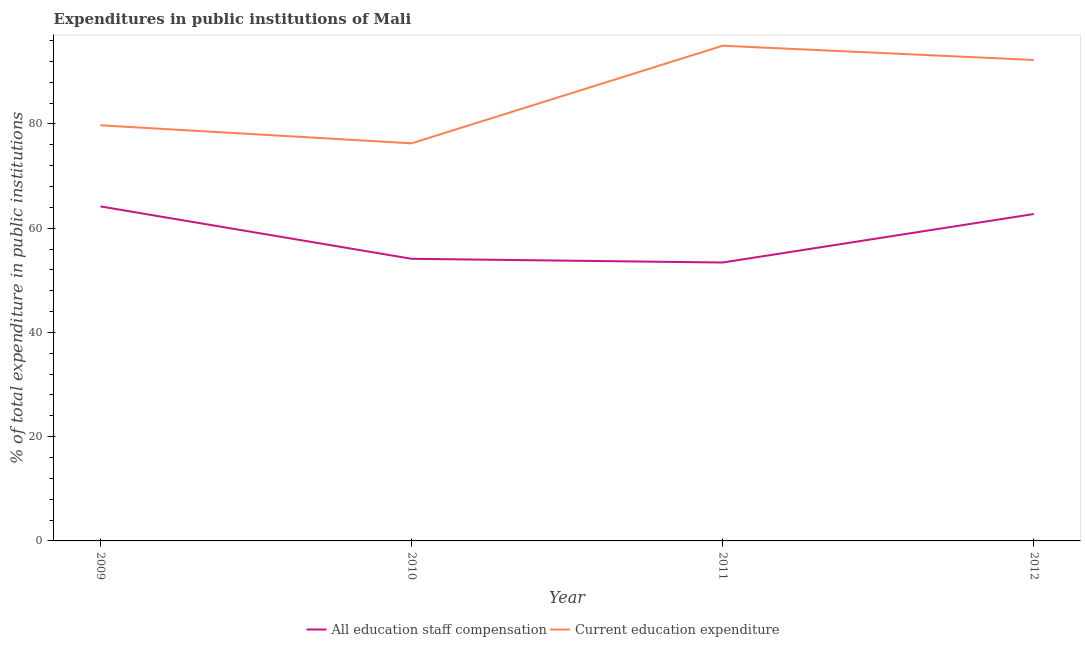How many different coloured lines are there?
Ensure brevity in your answer.  2. Does the line corresponding to expenditure in staff compensation intersect with the line corresponding to expenditure in education?
Ensure brevity in your answer.  No. What is the expenditure in education in 2012?
Keep it short and to the point. 92.28. Across all years, what is the maximum expenditure in education?
Ensure brevity in your answer.  95.02. Across all years, what is the minimum expenditure in staff compensation?
Ensure brevity in your answer.  53.42. What is the total expenditure in education in the graph?
Make the answer very short. 343.34. What is the difference between the expenditure in staff compensation in 2011 and that in 2012?
Give a very brief answer. -9.3. What is the difference between the expenditure in education in 2012 and the expenditure in staff compensation in 2011?
Keep it short and to the point. 38.86. What is the average expenditure in staff compensation per year?
Your response must be concise. 58.62. In the year 2011, what is the difference between the expenditure in staff compensation and expenditure in education?
Offer a very short reply. -41.6. What is the ratio of the expenditure in staff compensation in 2009 to that in 2012?
Give a very brief answer. 1.02. Is the difference between the expenditure in education in 2009 and 2011 greater than the difference between the expenditure in staff compensation in 2009 and 2011?
Provide a short and direct response. No. What is the difference between the highest and the second highest expenditure in staff compensation?
Offer a terse response. 1.46. What is the difference between the highest and the lowest expenditure in staff compensation?
Your response must be concise. 10.76. Does the expenditure in education monotonically increase over the years?
Your answer should be very brief. No. How many lines are there?
Provide a succinct answer. 2. What is the title of the graph?
Make the answer very short. Expenditures in public institutions of Mali. Does "Secondary education" appear as one of the legend labels in the graph?
Your response must be concise. No. What is the label or title of the X-axis?
Your answer should be very brief. Year. What is the label or title of the Y-axis?
Your answer should be compact. % of total expenditure in public institutions. What is the % of total expenditure in public institutions of All education staff compensation in 2009?
Ensure brevity in your answer.  64.19. What is the % of total expenditure in public institutions of Current education expenditure in 2009?
Provide a short and direct response. 79.75. What is the % of total expenditure in public institutions of All education staff compensation in 2010?
Offer a terse response. 54.13. What is the % of total expenditure in public institutions in Current education expenditure in 2010?
Offer a terse response. 76.29. What is the % of total expenditure in public institutions of All education staff compensation in 2011?
Provide a short and direct response. 53.42. What is the % of total expenditure in public institutions of Current education expenditure in 2011?
Offer a terse response. 95.02. What is the % of total expenditure in public institutions of All education staff compensation in 2012?
Give a very brief answer. 62.72. What is the % of total expenditure in public institutions of Current education expenditure in 2012?
Give a very brief answer. 92.28. Across all years, what is the maximum % of total expenditure in public institutions in All education staff compensation?
Offer a very short reply. 64.19. Across all years, what is the maximum % of total expenditure in public institutions of Current education expenditure?
Keep it short and to the point. 95.02. Across all years, what is the minimum % of total expenditure in public institutions of All education staff compensation?
Your answer should be compact. 53.42. Across all years, what is the minimum % of total expenditure in public institutions of Current education expenditure?
Make the answer very short. 76.29. What is the total % of total expenditure in public institutions in All education staff compensation in the graph?
Ensure brevity in your answer.  234.46. What is the total % of total expenditure in public institutions of Current education expenditure in the graph?
Make the answer very short. 343.34. What is the difference between the % of total expenditure in public institutions in All education staff compensation in 2009 and that in 2010?
Your answer should be compact. 10.05. What is the difference between the % of total expenditure in public institutions of Current education expenditure in 2009 and that in 2010?
Offer a terse response. 3.46. What is the difference between the % of total expenditure in public institutions of All education staff compensation in 2009 and that in 2011?
Provide a succinct answer. 10.76. What is the difference between the % of total expenditure in public institutions in Current education expenditure in 2009 and that in 2011?
Keep it short and to the point. -15.27. What is the difference between the % of total expenditure in public institutions in All education staff compensation in 2009 and that in 2012?
Your answer should be compact. 1.46. What is the difference between the % of total expenditure in public institutions in Current education expenditure in 2009 and that in 2012?
Make the answer very short. -12.53. What is the difference between the % of total expenditure in public institutions in All education staff compensation in 2010 and that in 2011?
Your response must be concise. 0.71. What is the difference between the % of total expenditure in public institutions of Current education expenditure in 2010 and that in 2011?
Your response must be concise. -18.73. What is the difference between the % of total expenditure in public institutions of All education staff compensation in 2010 and that in 2012?
Your response must be concise. -8.59. What is the difference between the % of total expenditure in public institutions in Current education expenditure in 2010 and that in 2012?
Provide a succinct answer. -15.99. What is the difference between the % of total expenditure in public institutions in All education staff compensation in 2011 and that in 2012?
Offer a terse response. -9.3. What is the difference between the % of total expenditure in public institutions of Current education expenditure in 2011 and that in 2012?
Make the answer very short. 2.74. What is the difference between the % of total expenditure in public institutions of All education staff compensation in 2009 and the % of total expenditure in public institutions of Current education expenditure in 2010?
Your response must be concise. -12.1. What is the difference between the % of total expenditure in public institutions in All education staff compensation in 2009 and the % of total expenditure in public institutions in Current education expenditure in 2011?
Offer a very short reply. -30.83. What is the difference between the % of total expenditure in public institutions in All education staff compensation in 2009 and the % of total expenditure in public institutions in Current education expenditure in 2012?
Give a very brief answer. -28.1. What is the difference between the % of total expenditure in public institutions in All education staff compensation in 2010 and the % of total expenditure in public institutions in Current education expenditure in 2011?
Keep it short and to the point. -40.89. What is the difference between the % of total expenditure in public institutions of All education staff compensation in 2010 and the % of total expenditure in public institutions of Current education expenditure in 2012?
Provide a short and direct response. -38.15. What is the difference between the % of total expenditure in public institutions of All education staff compensation in 2011 and the % of total expenditure in public institutions of Current education expenditure in 2012?
Provide a short and direct response. -38.86. What is the average % of total expenditure in public institutions of All education staff compensation per year?
Provide a short and direct response. 58.62. What is the average % of total expenditure in public institutions in Current education expenditure per year?
Give a very brief answer. 85.83. In the year 2009, what is the difference between the % of total expenditure in public institutions in All education staff compensation and % of total expenditure in public institutions in Current education expenditure?
Keep it short and to the point. -15.56. In the year 2010, what is the difference between the % of total expenditure in public institutions of All education staff compensation and % of total expenditure in public institutions of Current education expenditure?
Your answer should be compact. -22.16. In the year 2011, what is the difference between the % of total expenditure in public institutions in All education staff compensation and % of total expenditure in public institutions in Current education expenditure?
Make the answer very short. -41.6. In the year 2012, what is the difference between the % of total expenditure in public institutions of All education staff compensation and % of total expenditure in public institutions of Current education expenditure?
Your answer should be compact. -29.56. What is the ratio of the % of total expenditure in public institutions of All education staff compensation in 2009 to that in 2010?
Offer a very short reply. 1.19. What is the ratio of the % of total expenditure in public institutions of Current education expenditure in 2009 to that in 2010?
Offer a terse response. 1.05. What is the ratio of the % of total expenditure in public institutions in All education staff compensation in 2009 to that in 2011?
Provide a succinct answer. 1.2. What is the ratio of the % of total expenditure in public institutions in Current education expenditure in 2009 to that in 2011?
Offer a very short reply. 0.84. What is the ratio of the % of total expenditure in public institutions of All education staff compensation in 2009 to that in 2012?
Give a very brief answer. 1.02. What is the ratio of the % of total expenditure in public institutions of Current education expenditure in 2009 to that in 2012?
Your response must be concise. 0.86. What is the ratio of the % of total expenditure in public institutions of All education staff compensation in 2010 to that in 2011?
Offer a very short reply. 1.01. What is the ratio of the % of total expenditure in public institutions of Current education expenditure in 2010 to that in 2011?
Give a very brief answer. 0.8. What is the ratio of the % of total expenditure in public institutions in All education staff compensation in 2010 to that in 2012?
Provide a short and direct response. 0.86. What is the ratio of the % of total expenditure in public institutions of Current education expenditure in 2010 to that in 2012?
Ensure brevity in your answer.  0.83. What is the ratio of the % of total expenditure in public institutions in All education staff compensation in 2011 to that in 2012?
Your answer should be compact. 0.85. What is the ratio of the % of total expenditure in public institutions of Current education expenditure in 2011 to that in 2012?
Make the answer very short. 1.03. What is the difference between the highest and the second highest % of total expenditure in public institutions in All education staff compensation?
Give a very brief answer. 1.46. What is the difference between the highest and the second highest % of total expenditure in public institutions in Current education expenditure?
Keep it short and to the point. 2.74. What is the difference between the highest and the lowest % of total expenditure in public institutions in All education staff compensation?
Your answer should be very brief. 10.76. What is the difference between the highest and the lowest % of total expenditure in public institutions of Current education expenditure?
Offer a very short reply. 18.73. 